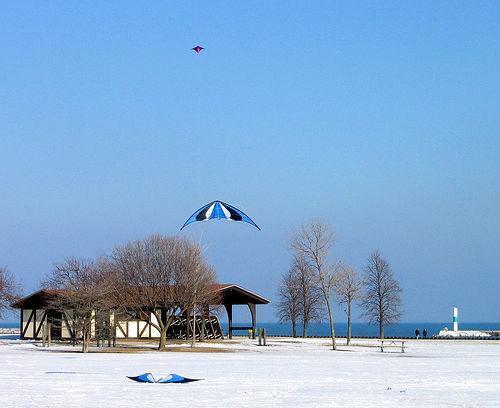How many people are pictured?
Give a very brief answer. 2. 